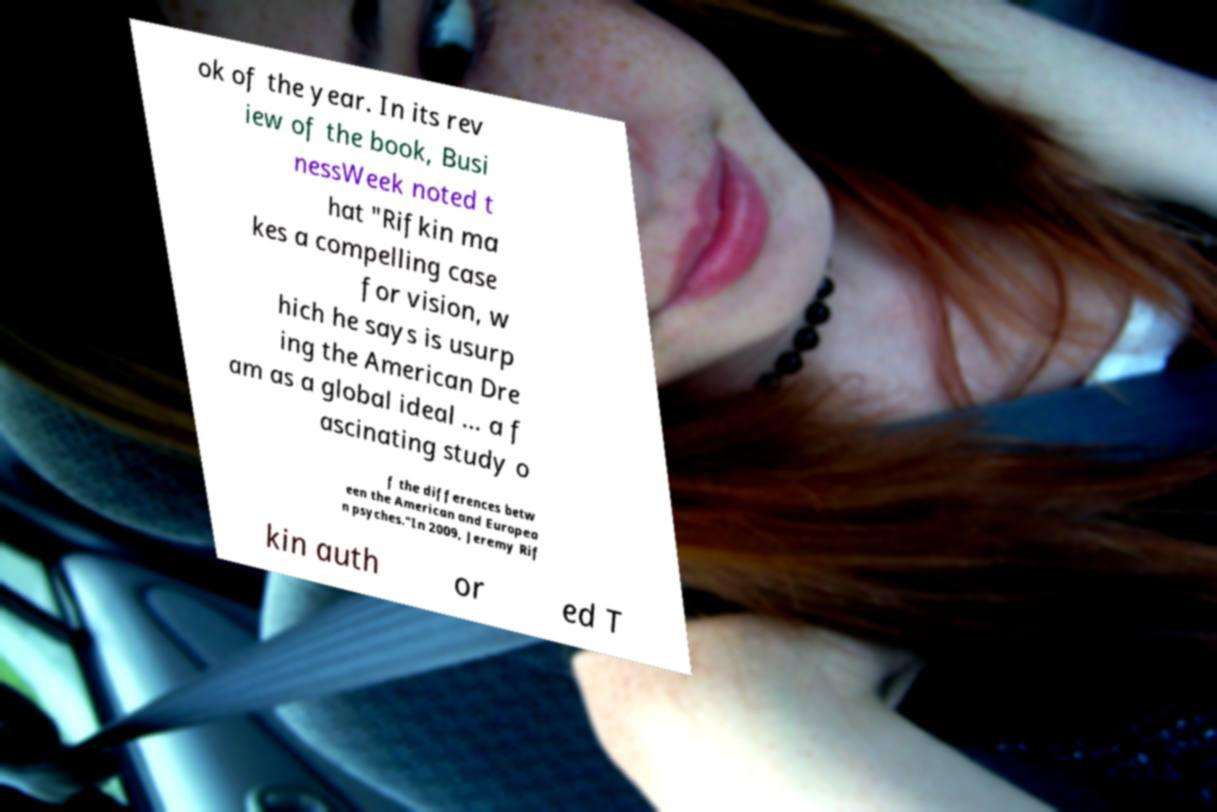Can you read and provide the text displayed in the image?This photo seems to have some interesting text. Can you extract and type it out for me? ok of the year. In its rev iew of the book, Busi nessWeek noted t hat "Rifkin ma kes a compelling case for vision, w hich he says is usurp ing the American Dre am as a global ideal … a f ascinating study o f the differences betw een the American and Europea n psyches."In 2009, Jeremy Rif kin auth or ed T 